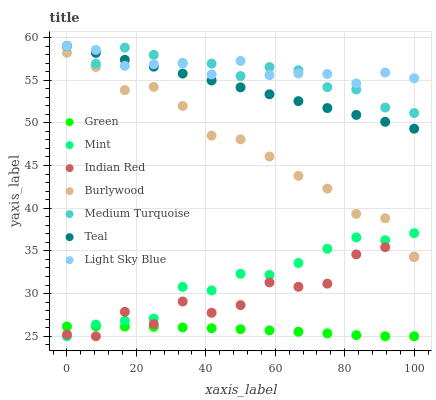Does Green have the minimum area under the curve?
Answer yes or no. Yes. Does Light Sky Blue have the maximum area under the curve?
Answer yes or no. Yes. Does Burlywood have the minimum area under the curve?
Answer yes or no. No. Does Burlywood have the maximum area under the curve?
Answer yes or no. No. Is Teal the smoothest?
Answer yes or no. Yes. Is Indian Red the roughest?
Answer yes or no. Yes. Is Burlywood the smoothest?
Answer yes or no. No. Is Burlywood the roughest?
Answer yes or no. No. Does Green have the lowest value?
Answer yes or no. Yes. Does Burlywood have the lowest value?
Answer yes or no. No. Does Teal have the highest value?
Answer yes or no. Yes. Does Burlywood have the highest value?
Answer yes or no. No. Is Burlywood less than Teal?
Answer yes or no. Yes. Is Medium Turquoise greater than Green?
Answer yes or no. Yes. Does Green intersect Indian Red?
Answer yes or no. Yes. Is Green less than Indian Red?
Answer yes or no. No. Is Green greater than Indian Red?
Answer yes or no. No. Does Burlywood intersect Teal?
Answer yes or no. No. 